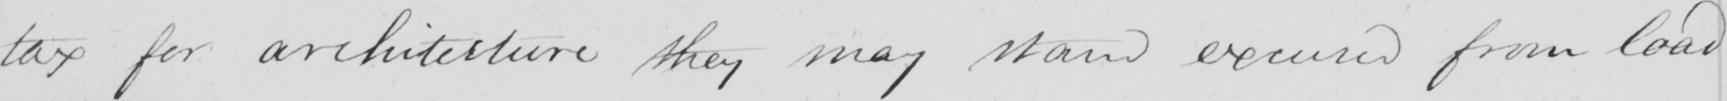What text is written in this handwritten line? tax for architecture they may stand excused from load- 